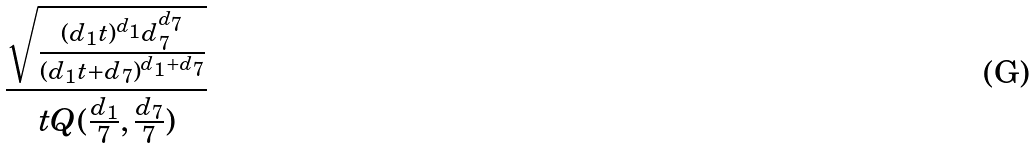Convert formula to latex. <formula><loc_0><loc_0><loc_500><loc_500>\frac { \sqrt { \frac { ( d _ { 1 } t ) ^ { d _ { 1 } } d _ { 7 } ^ { d _ { 7 } } } { ( d _ { 1 } t + d _ { 7 } ) ^ { d _ { 1 } + d _ { 7 } } } } } { t Q ( \frac { d _ { 1 } } { 7 } , \frac { d _ { 7 } } { 7 } ) }</formula> 